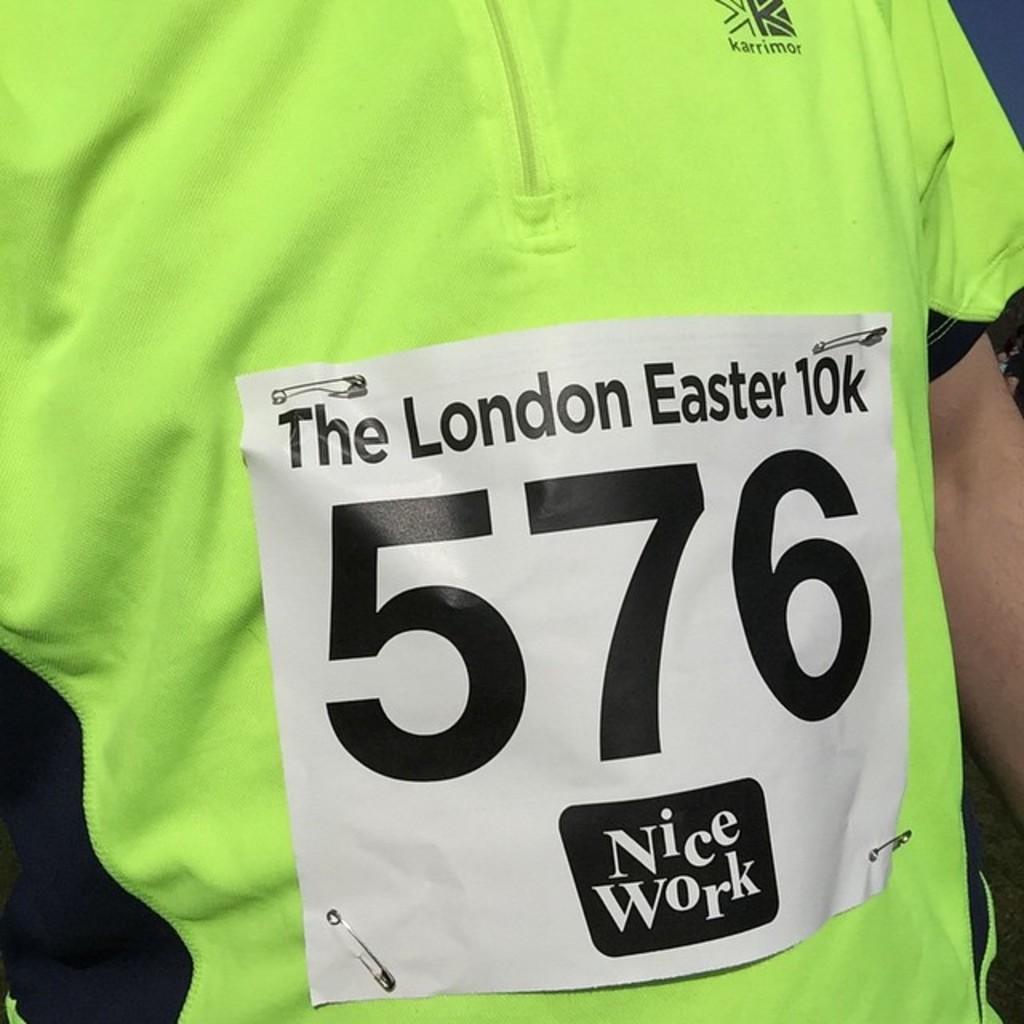What race is he running in?
Your response must be concise. The london easter 10k. What is the runner's number?
Your answer should be compact. 576. 